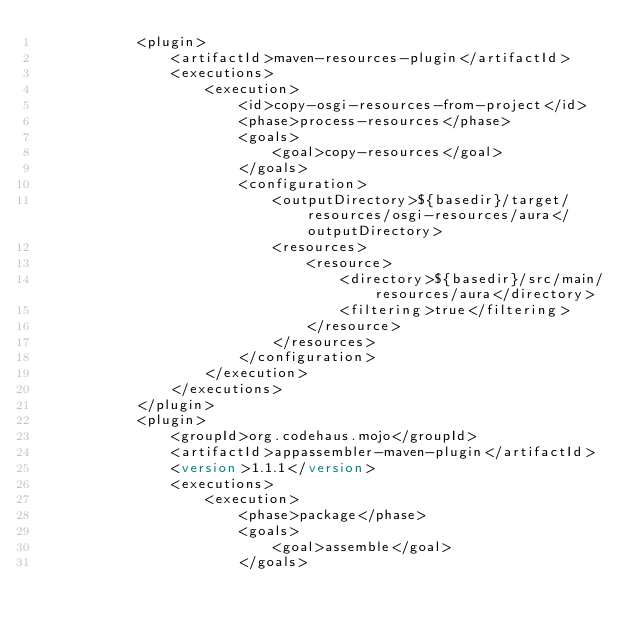<code> <loc_0><loc_0><loc_500><loc_500><_XML_>            <plugin>
                <artifactId>maven-resources-plugin</artifactId>
                <executions>
                    <execution>
                        <id>copy-osgi-resources-from-project</id>
                        <phase>process-resources</phase>
                        <goals>
                            <goal>copy-resources</goal>
                        </goals>
                        <configuration>
                            <outputDirectory>${basedir}/target/resources/osgi-resources/aura</outputDirectory>
                            <resources>
                                <resource>
                                    <directory>${basedir}/src/main/resources/aura</directory>
                                    <filtering>true</filtering>
                                </resource>
                            </resources>
                        </configuration>
                    </execution>
                </executions>
            </plugin>
            <plugin>
                <groupId>org.codehaus.mojo</groupId>
                <artifactId>appassembler-maven-plugin</artifactId>
                <version>1.1.1</version>
                <executions>
                    <execution>
                        <phase>package</phase>
                        <goals>
                            <goal>assemble</goal>
                        </goals></code> 